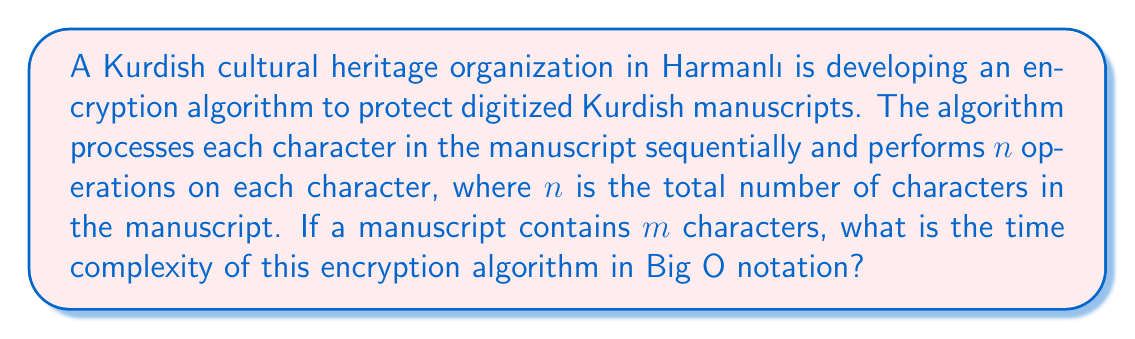Could you help me with this problem? Let's approach this step-by-step:

1) For each character in the manuscript, the algorithm performs $n$ operations.

2) There are $m$ characters in total in the manuscript.

3) Therefore, for each character, $n$ operations are performed, and this is done $m$ times.

4) This results in a total of $n \times m$ operations.

5) In Big O notation, we express this as $O(n \times m)$.

6) However, we need to consider that $n = m$, since $n$ is defined as the total number of characters in the manuscript, which is the same as $m$.

7) Substituting $n$ with $m$, we get:

   $O(m \times m) = O(m^2)$

Therefore, the time complexity of this encryption algorithm is quadratic, or $O(m^2)$, where $m$ is the number of characters in the manuscript.
Answer: $O(m^2)$ 